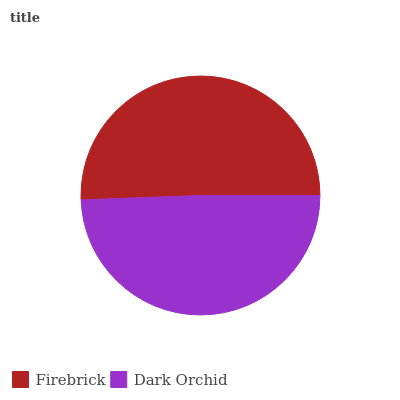Is Dark Orchid the minimum?
Answer yes or no. Yes. Is Firebrick the maximum?
Answer yes or no. Yes. Is Dark Orchid the maximum?
Answer yes or no. No. Is Firebrick greater than Dark Orchid?
Answer yes or no. Yes. Is Dark Orchid less than Firebrick?
Answer yes or no. Yes. Is Dark Orchid greater than Firebrick?
Answer yes or no. No. Is Firebrick less than Dark Orchid?
Answer yes or no. No. Is Firebrick the high median?
Answer yes or no. Yes. Is Dark Orchid the low median?
Answer yes or no. Yes. Is Dark Orchid the high median?
Answer yes or no. No. Is Firebrick the low median?
Answer yes or no. No. 